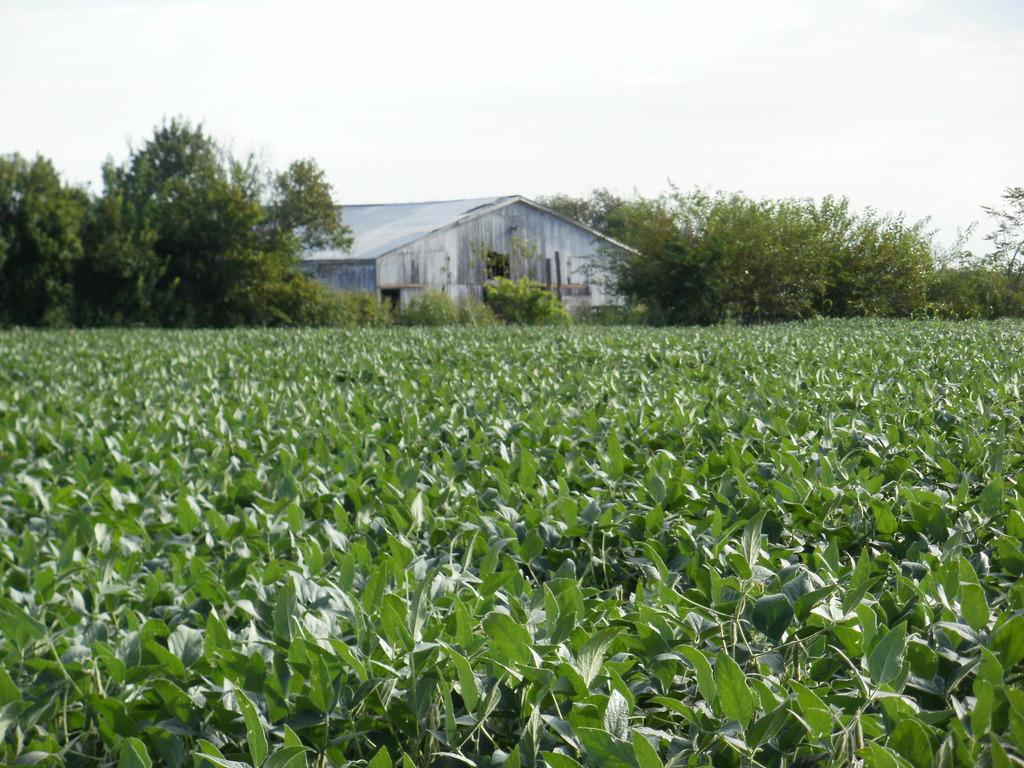What type of living organisms can be seen in the image? Plants can be seen in the image. What is visible in the background of the image? There is a house and trees in the background of the image. What riddle does the brother solve in the image? There is no brother or riddle present in the image. 